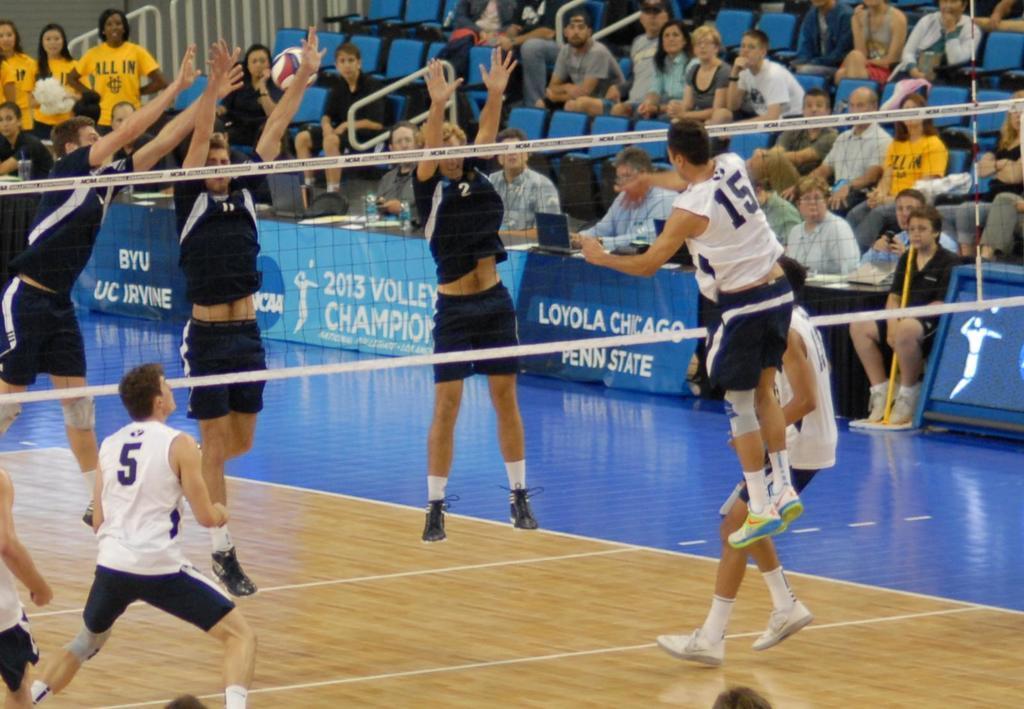Describe this image in one or two sentences. Here two teams are playing volleyball to the either side of the net and we can see few people are on the court and few are jumping. In the background there are audience sitting on the chairs and judges sitting on the chair at the table. On the table there are water bottles and some other items,hoardings and on the left there are three women standing at the fence. 